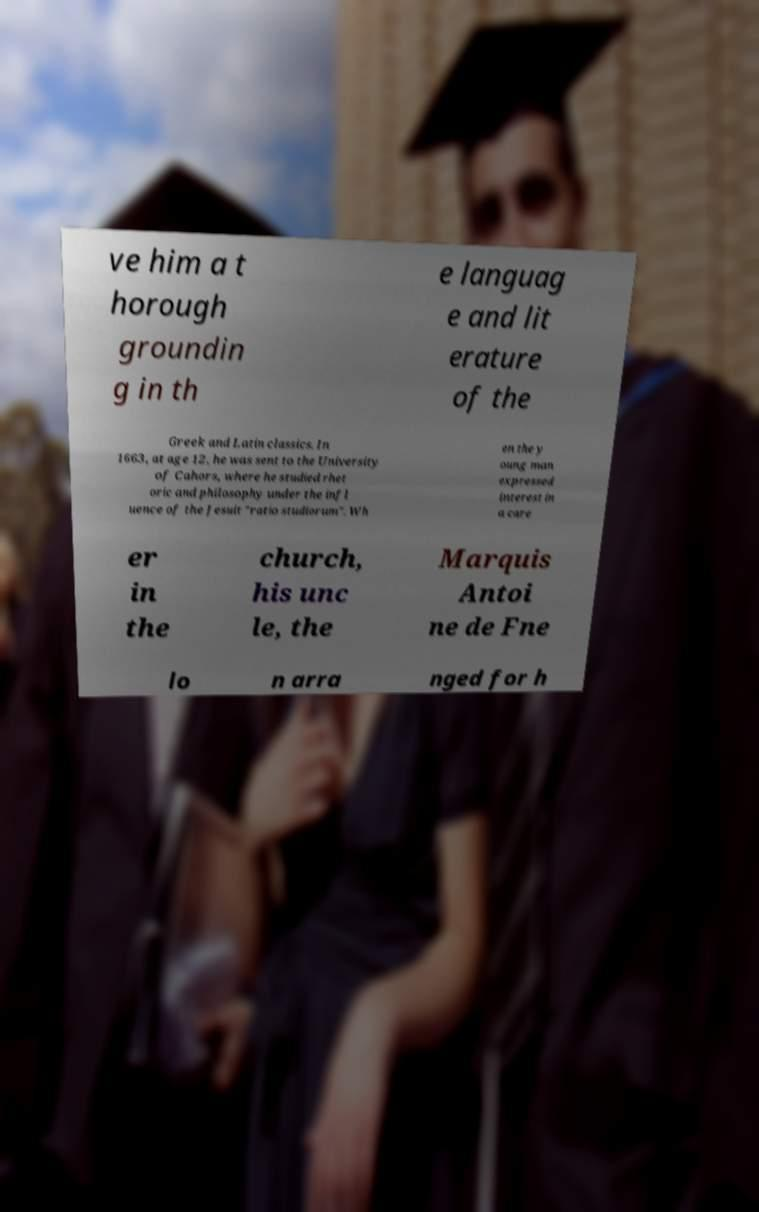Could you extract and type out the text from this image? ve him a t horough groundin g in th e languag e and lit erature of the Greek and Latin classics. In 1663, at age 12, he was sent to the University of Cahors, where he studied rhet oric and philosophy under the infl uence of the Jesuit "ratio studiorum". Wh en the y oung man expressed interest in a care er in the church, his unc le, the Marquis Antoi ne de Fne lo n arra nged for h 